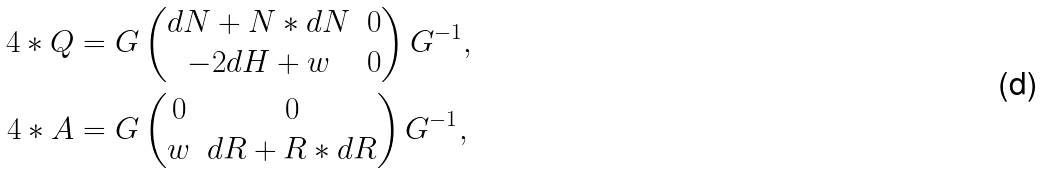<formula> <loc_0><loc_0><loc_500><loc_500>4 * Q & = G \begin{pmatrix} d N + N * d N & 0 \\ - 2 d H + w & 0 \end{pmatrix} G ^ { - 1 } , \\ 4 * A & = G \begin{pmatrix} 0 & 0 \\ w & d R + R * d R \end{pmatrix} G ^ { - 1 } ,</formula> 